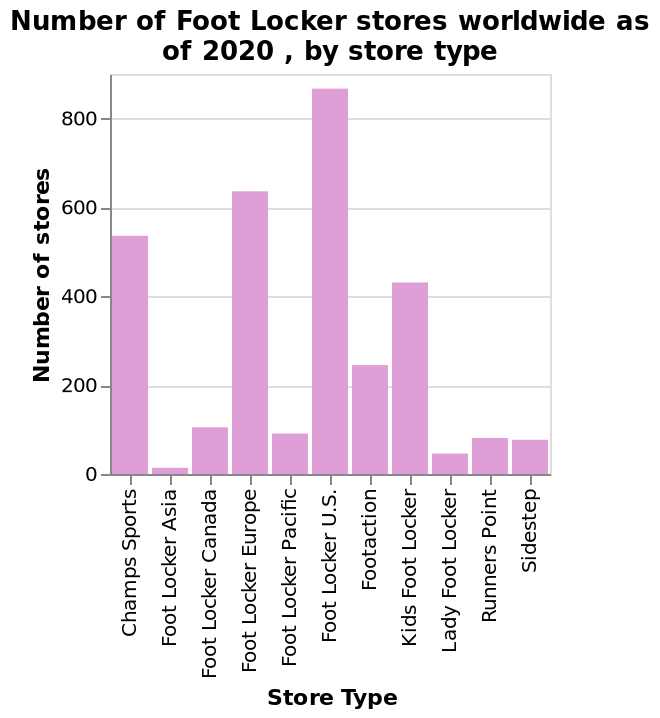<image>
What does the chart reveal about the number of Footlocker stores in the US compared to the rest of the world?  The chart shows that the number of Footlocker stores is significantly higher in the US than anywhere else in the world. please describe the details of the chart Number of Foot Locker stores worldwide as of 2020 , by store type is a bar graph. The y-axis shows Number of stores using linear scale with a minimum of 0 and a maximum of 800 while the x-axis plots Store Type as categorical scale with Champs Sports on one end and Sidestep at the other. Does the line graph represent the number of Foot Locker stores worldwide as of 2020, by store type? No.Number of Foot Locker stores worldwide as of 2020 , by store type is a bar graph. The y-axis shows Number of stores using linear scale with a minimum of 0 and a maximum of 800 while the x-axis plots Store Type as categorical scale with Champs Sports on one end and Sidestep at the other. 